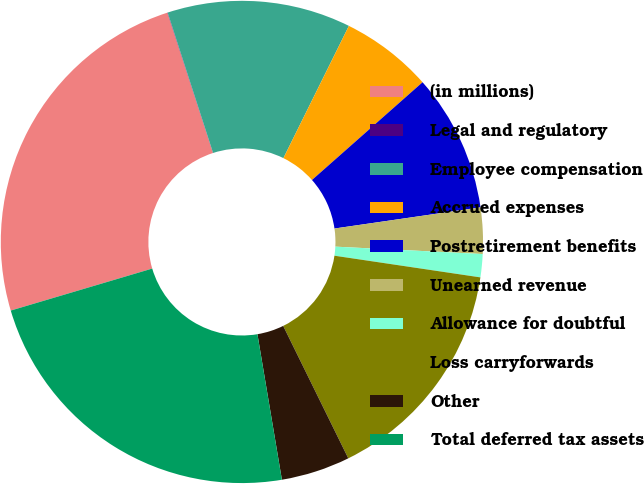<chart> <loc_0><loc_0><loc_500><loc_500><pie_chart><fcel>(in millions)<fcel>Legal and regulatory<fcel>Employee compensation<fcel>Accrued expenses<fcel>Postretirement benefits<fcel>Unearned revenue<fcel>Allowance for doubtful<fcel>Loss carryforwards<fcel>Other<fcel>Total deferred tax assets<nl><fcel>24.59%<fcel>0.02%<fcel>12.3%<fcel>6.16%<fcel>9.23%<fcel>3.09%<fcel>1.55%<fcel>15.38%<fcel>4.62%<fcel>23.06%<nl></chart> 